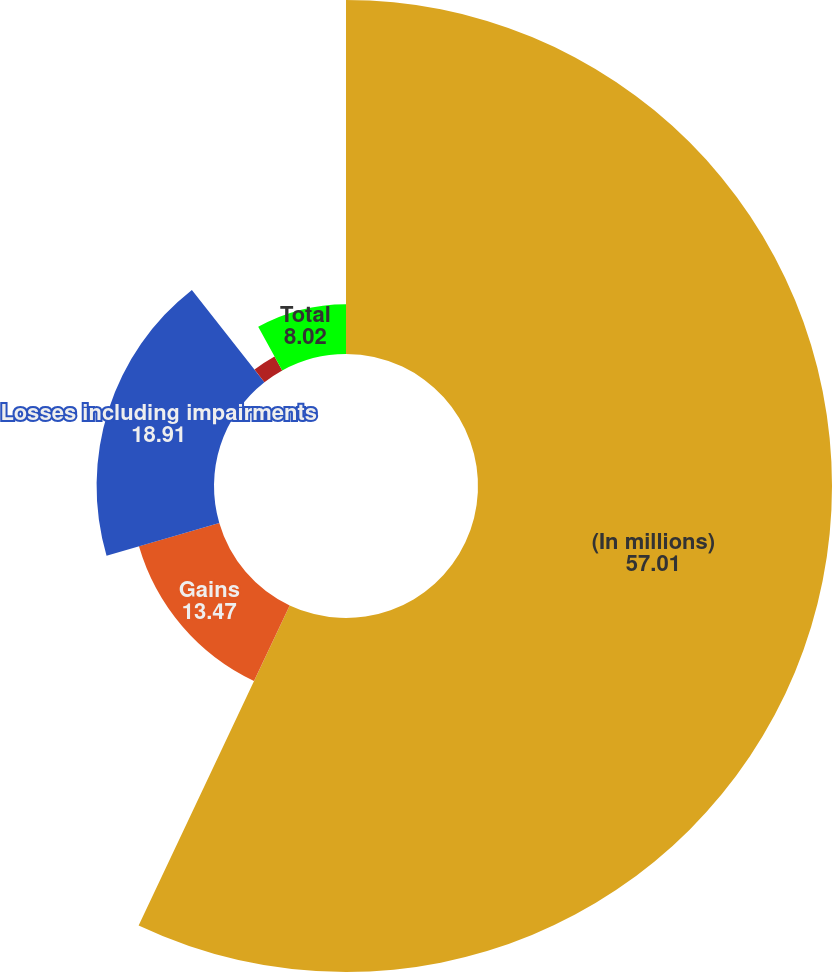Convert chart. <chart><loc_0><loc_0><loc_500><loc_500><pie_chart><fcel>(In millions)<fcel>Gains<fcel>Losses including impairments<fcel>Net<fcel>Total<nl><fcel>57.01%<fcel>13.47%<fcel>18.91%<fcel>2.58%<fcel>8.02%<nl></chart> 